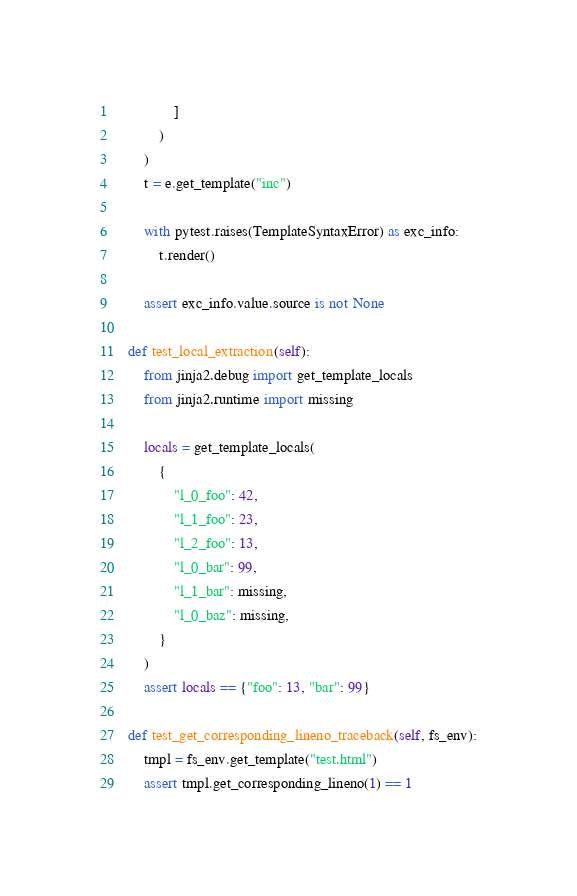Convert code to text. <code><loc_0><loc_0><loc_500><loc_500><_Python_>                ]
            )
        )
        t = e.get_template("inc")

        with pytest.raises(TemplateSyntaxError) as exc_info:
            t.render()

        assert exc_info.value.source is not None

    def test_local_extraction(self):
        from jinja2.debug import get_template_locals
        from jinja2.runtime import missing

        locals = get_template_locals(
            {
                "l_0_foo": 42,
                "l_1_foo": 23,
                "l_2_foo": 13,
                "l_0_bar": 99,
                "l_1_bar": missing,
                "l_0_baz": missing,
            }
        )
        assert locals == {"foo": 13, "bar": 99}

    def test_get_corresponding_lineno_traceback(self, fs_env):
        tmpl = fs_env.get_template("test.html")
        assert tmpl.get_corresponding_lineno(1) == 1
</code> 